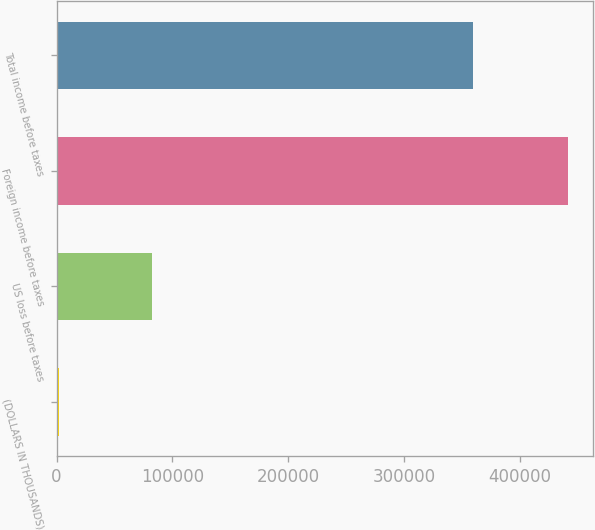Convert chart. <chart><loc_0><loc_0><loc_500><loc_500><bar_chart><fcel>(DOLLARS IN THOUSANDS)<fcel>US loss before taxes<fcel>Foreign income before taxes<fcel>Total income before taxes<nl><fcel>2010<fcel>82112<fcel>441705<fcel>359593<nl></chart> 